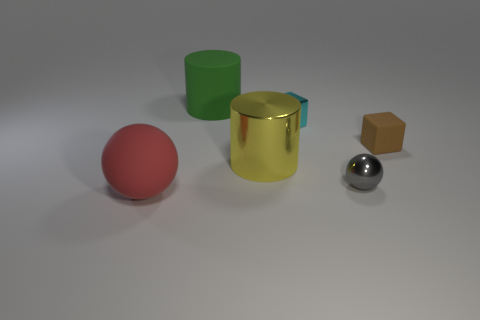How would these objects behave if the table they're resting on suddenly disappeared? If the table were to disappear suddenly, each object would respond according to its physical properties and the law of gravity. They would all fall to the ground due to gravity's pull. The rubber ball might bounce slightly upon impact, while the metallic objects would likely produce a louder noise due to their higher density and hardness. The tiny box would fall as well but may not make much noise depending on its weight and material. 